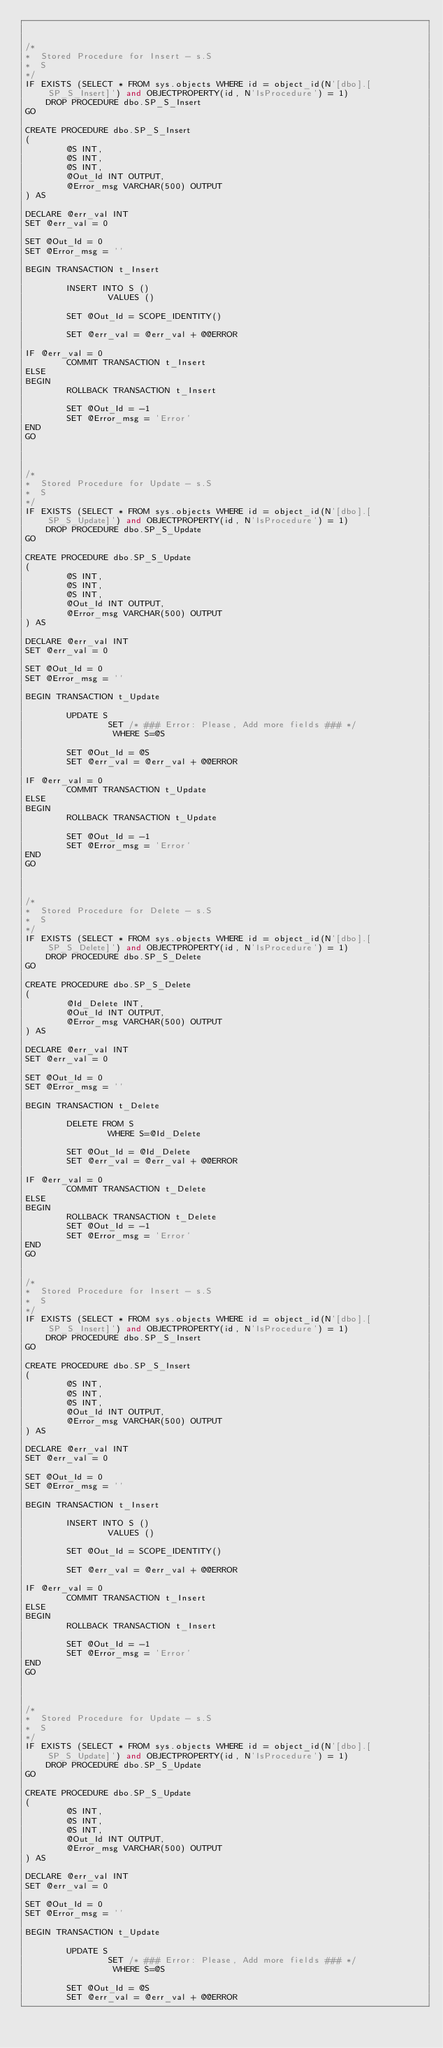<code> <loc_0><loc_0><loc_500><loc_500><_SQL_>

/* 
*  Stored Procedure for Insert - s.S
*  S
*/ 
IF EXISTS (SELECT * FROM sys.objects WHERE id = object_id(N'[dbo].[SP_S_Insert]') and OBJECTPROPERTY(id, N'IsProcedure') = 1) 
    DROP PROCEDURE dbo.SP_S_Insert 
GO

CREATE PROCEDURE dbo.SP_S_Insert
(
        @S INT,
        @S INT,
        @S INT,
        @Out_Id INT OUTPUT, 
        @Error_msg VARCHAR(500) OUTPUT
) AS 

DECLARE @err_val INT
SET @err_val = 0

SET @Out_Id = 0
SET @Error_msg = ''

BEGIN TRANSACTION t_Insert

        INSERT INTO S ()
                VALUES ()

        SET @Out_Id = SCOPE_IDENTITY()

        SET @err_val = @err_val + @@ERROR

IF @err_val = 0
        COMMIT TRANSACTION t_Insert
ELSE 
BEGIN 
        ROLLBACK TRANSACTION t_Insert

        SET @Out_Id = -1
        SET @Error_msg = 'Error'
END 
GO



/* 
*  Stored Procedure for Update - s.S
*  S
*/ 
IF EXISTS (SELECT * FROM sys.objects WHERE id = object_id(N'[dbo].[SP_S_Update]') and OBJECTPROPERTY(id, N'IsProcedure') = 1) 
    DROP PROCEDURE dbo.SP_S_Update 
GO

CREATE PROCEDURE dbo.SP_S_Update 
(
        @S INT,
        @S INT,
        @S INT,
        @Out_Id INT OUTPUT, 
        @Error_msg VARCHAR(500) OUTPUT
) AS 

DECLARE @err_val INT
SET @err_val = 0

SET @Out_Id = 0
SET @Error_msg = ''

BEGIN TRANSACTION t_Update

        UPDATE S
                SET /* ### Error: Please, Add more fields ### */
                 WHERE S=@S

        SET @Out_Id = @S
        SET @err_val = @err_val + @@ERROR

IF @err_val = 0
        COMMIT TRANSACTION t_Update
ELSE 
BEGIN 
        ROLLBACK TRANSACTION t_Update

        SET @Out_Id = -1
        SET @Error_msg = 'Error'
END 
GO



/* 
*  Stored Procedure for Delete - s.S
*  S
*/ 
IF EXISTS (SELECT * FROM sys.objects WHERE id = object_id(N'[dbo].[SP_S_Delete]') and OBJECTPROPERTY(id, N'IsProcedure') = 1) 
    DROP PROCEDURE dbo.SP_S_Delete 
GO

CREATE PROCEDURE dbo.SP_S_Delete 
(
        @Id_Delete INT, 
        @Out_Id INT OUTPUT, 
        @Error_msg VARCHAR(500) OUTPUT
) AS 

DECLARE @err_val INT
SET @err_val = 0

SET @Out_Id = 0
SET @Error_msg = ''

BEGIN TRANSACTION t_Delete

        DELETE FROM S 
                WHERE S=@Id_Delete

        SET @Out_Id = @Id_Delete
        SET @err_val = @err_val + @@ERROR

IF @err_val = 0
        COMMIT TRANSACTION t_Delete
ELSE 
BEGIN 
        ROLLBACK TRANSACTION t_Delete
        SET @Out_Id = -1
        SET @Error_msg = 'Error'
END 
GO


/* 
*  Stored Procedure for Insert - s.S
*  S
*/ 
IF EXISTS (SELECT * FROM sys.objects WHERE id = object_id(N'[dbo].[SP_S_Insert]') and OBJECTPROPERTY(id, N'IsProcedure') = 1) 
    DROP PROCEDURE dbo.SP_S_Insert 
GO

CREATE PROCEDURE dbo.SP_S_Insert
(
        @S INT,
        @S INT,
        @S INT,
        @Out_Id INT OUTPUT, 
        @Error_msg VARCHAR(500) OUTPUT
) AS 

DECLARE @err_val INT
SET @err_val = 0

SET @Out_Id = 0
SET @Error_msg = ''

BEGIN TRANSACTION t_Insert

        INSERT INTO S ()
                VALUES ()

        SET @Out_Id = SCOPE_IDENTITY()

        SET @err_val = @err_val + @@ERROR

IF @err_val = 0
        COMMIT TRANSACTION t_Insert
ELSE 
BEGIN 
        ROLLBACK TRANSACTION t_Insert

        SET @Out_Id = -1
        SET @Error_msg = 'Error'
END 
GO



/* 
*  Stored Procedure for Update - s.S
*  S
*/ 
IF EXISTS (SELECT * FROM sys.objects WHERE id = object_id(N'[dbo].[SP_S_Update]') and OBJECTPROPERTY(id, N'IsProcedure') = 1) 
    DROP PROCEDURE dbo.SP_S_Update 
GO

CREATE PROCEDURE dbo.SP_S_Update 
(
        @S INT,
        @S INT,
        @S INT,
        @Out_Id INT OUTPUT, 
        @Error_msg VARCHAR(500) OUTPUT
) AS 

DECLARE @err_val INT
SET @err_val = 0

SET @Out_Id = 0
SET @Error_msg = ''

BEGIN TRANSACTION t_Update

        UPDATE S
                SET /* ### Error: Please, Add more fields ### */
                 WHERE S=@S

        SET @Out_Id = @S
        SET @err_val = @err_val + @@ERROR
</code> 